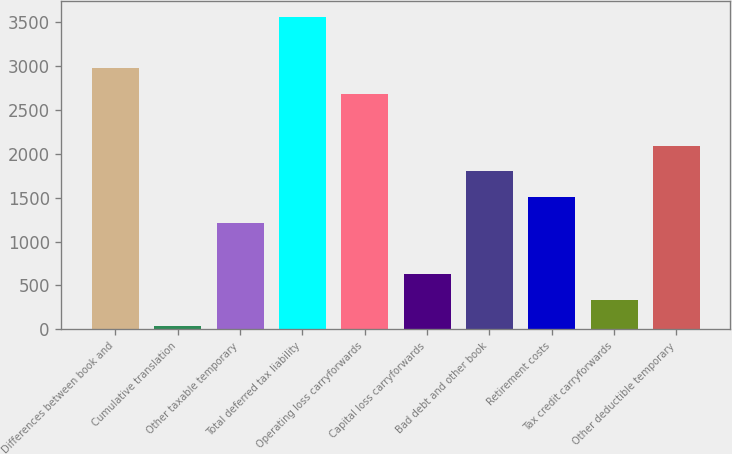<chart> <loc_0><loc_0><loc_500><loc_500><bar_chart><fcel>Differences between book and<fcel>Cumulative translation<fcel>Other taxable temporary<fcel>Total deferred tax liability<fcel>Operating loss carryforwards<fcel>Capital loss carryforwards<fcel>Bad debt and other book<fcel>Retirement costs<fcel>Tax credit carryforwards<fcel>Other deductible temporary<nl><fcel>2978<fcel>39<fcel>1214.6<fcel>3565.8<fcel>2684.1<fcel>626.8<fcel>1802.4<fcel>1508.5<fcel>332.9<fcel>2096.3<nl></chart> 